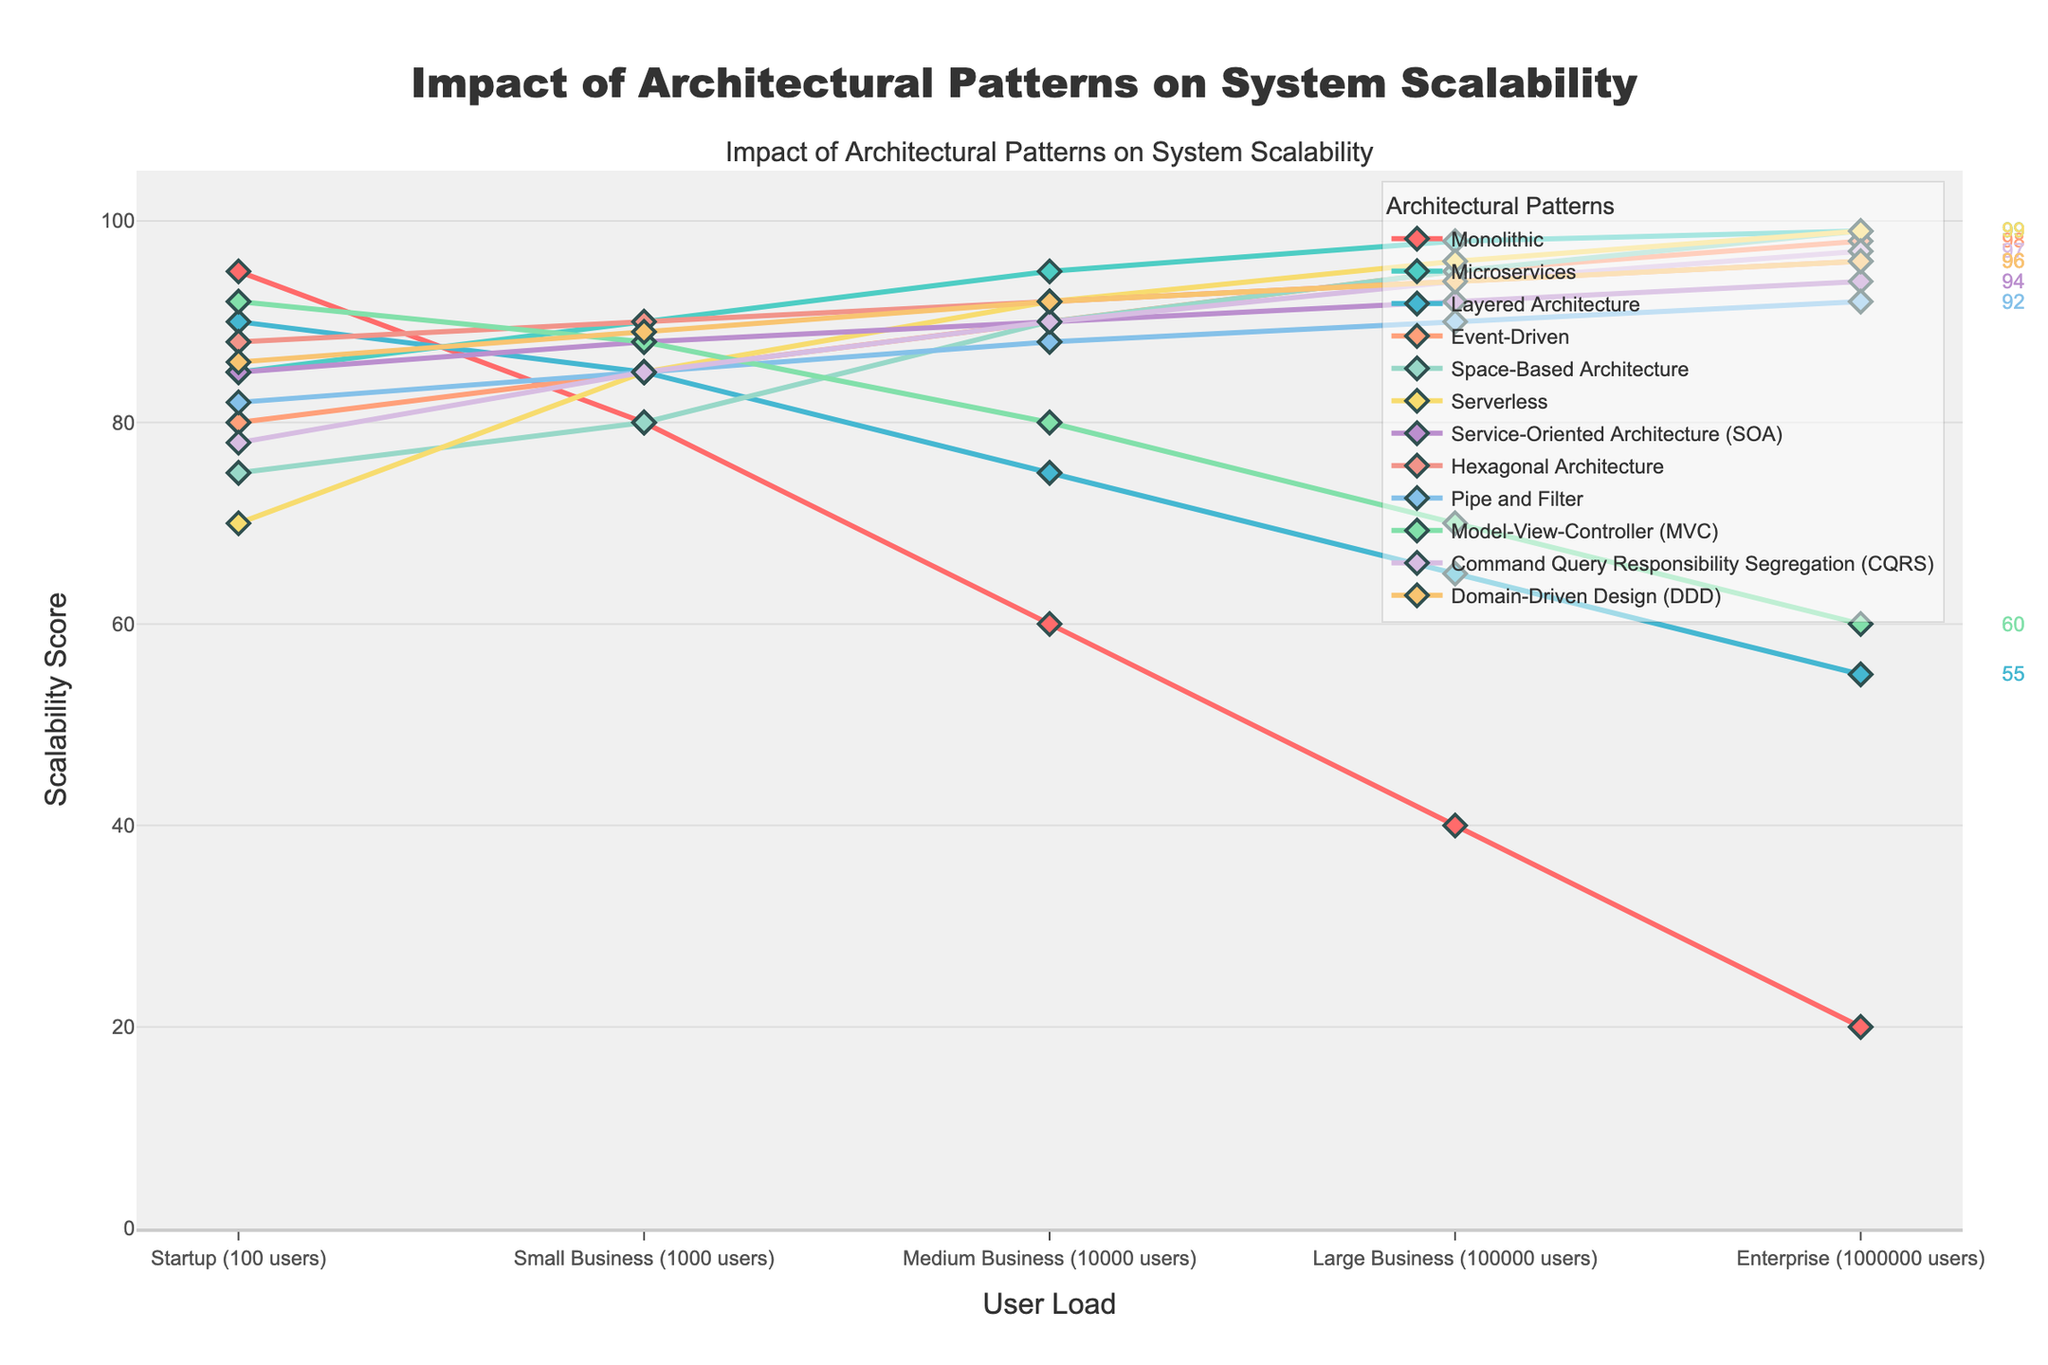What pattern shows the highest scalability score at the Enterprise level? To find the pattern with the highest scalability score at the Enterprise level, look for the tallest marker at the Enterprise (1000000 users) point on the x-axis.
Answer: Microservices, Space-Based Architecture, Serverless (all have 99) At what user load does the Monolithic pattern's scalability score fall below 50? Locate the Monolithic pattern’s line and identify the point on the x-axis where its scalability score, shown on the y-axis, drops below 50.
Answer: Large Business (100000 users) Compare the scalability scores of Microservices and Layered Architecture at Small Business (1000 users). Which is higher? Find the points for Microservices and Layered Architecture at the Small Business user load and compare their y-values.
Answer: Microservices Which architectural pattern shows a continual increase in scalability from Startup to Enterprise level without any decline? Examine all patterns and check if their scalability scores increase at each consecutive user load level from Startup to Enterprise.
Answer: Microservices, Event-Driven, Space-Based Architecture, Serverless, Hexagonal Architecture, CQRS, Domain-Driven Design (DDD) What is the difference in scalability scores between Hexagonal Architecture and MVC at Medium Business (10000 users)? Identify the scalability scores for Hexagonal Architecture and MVC at the Medium Business level, then subtract the MVC score from the Hexagonal Architecture score.
Answer: 12 (Hexagonal: 92, MVC: 80) Which pattern has the least scalability score at Startup level? Look for the pattern with the smallest point marker on the y-axis at the Startup (100 users) level.
Answer: Serverless What is the average scalability score of Layered Architecture across all user loads? Add up the scalability scores of the Layered Architecture at all user loads and divide by the number of loads (5).
Answer: 73 ( (90+85+75+65+55) / 5 ) How many architectural patterns have scalability scores of at least 90 at the Enterprise level? Count the number of patterns that have points at or above the 90 mark on the y-axis at the Enterprise user load.
Answer: 7 (Microservices, Event-Driven, Space-Based Architecture, Serverless, CQRS, Domain-Driven Design, Hexagonal Architecture) Which patterns have a higher scalability score than Service-Oriented Architecture (SOA) at Medium Business level? Compare the point markers of all patterns to that of SOA at the Medium Business level to see which are higher.
Answer: Hexagonal, Serverless, Space-Based Architecture, CQRS What is the total scalability score of Event-Driven architecture from Startup to Enterprise level? Sum the scalability scores of the Event-Driven architecture across all user loads.
Answer: 448 (80+85+90+95+98) 